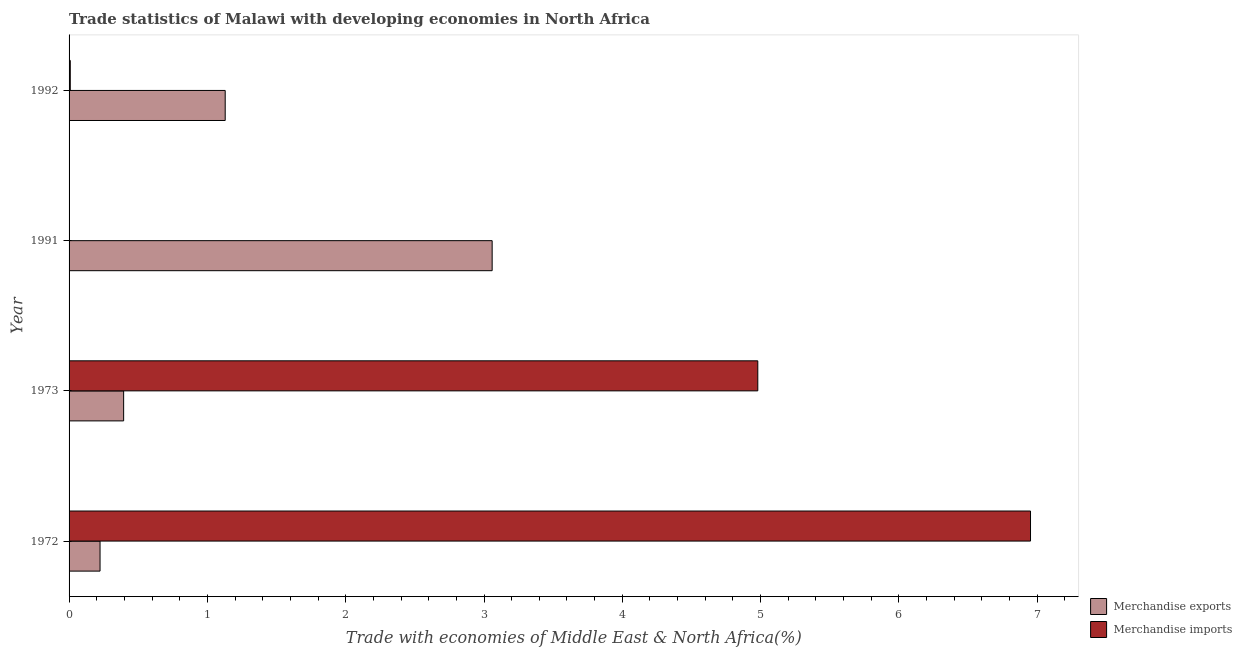Are the number of bars per tick equal to the number of legend labels?
Your response must be concise. Yes. Are the number of bars on each tick of the Y-axis equal?
Offer a very short reply. Yes. How many bars are there on the 2nd tick from the bottom?
Provide a succinct answer. 2. What is the label of the 3rd group of bars from the top?
Offer a terse response. 1973. In how many cases, is the number of bars for a given year not equal to the number of legend labels?
Provide a succinct answer. 0. What is the merchandise imports in 1972?
Keep it short and to the point. 6.95. Across all years, what is the maximum merchandise exports?
Offer a terse response. 3.06. Across all years, what is the minimum merchandise exports?
Your response must be concise. 0.22. What is the total merchandise imports in the graph?
Provide a succinct answer. 11.94. What is the difference between the merchandise exports in 1972 and that in 1991?
Provide a succinct answer. -2.83. What is the difference between the merchandise imports in 1972 and the merchandise exports in 1991?
Offer a terse response. 3.89. What is the average merchandise imports per year?
Ensure brevity in your answer.  2.98. In the year 1992, what is the difference between the merchandise imports and merchandise exports?
Ensure brevity in your answer.  -1.12. In how many years, is the merchandise exports greater than 3.8 %?
Offer a very short reply. 0. What is the ratio of the merchandise imports in 1972 to that in 1992?
Your answer should be very brief. 805.61. What is the difference between the highest and the second highest merchandise imports?
Provide a succinct answer. 1.97. What is the difference between the highest and the lowest merchandise exports?
Your response must be concise. 2.83. Is the sum of the merchandise imports in 1972 and 1992 greater than the maximum merchandise exports across all years?
Your response must be concise. Yes. How many bars are there?
Offer a very short reply. 8. Are all the bars in the graph horizontal?
Give a very brief answer. Yes. What is the difference between two consecutive major ticks on the X-axis?
Provide a succinct answer. 1. Are the values on the major ticks of X-axis written in scientific E-notation?
Ensure brevity in your answer.  No. Does the graph contain any zero values?
Provide a short and direct response. No. Does the graph contain grids?
Your answer should be very brief. No. Where does the legend appear in the graph?
Offer a terse response. Bottom right. What is the title of the graph?
Provide a succinct answer. Trade statistics of Malawi with developing economies in North Africa. What is the label or title of the X-axis?
Make the answer very short. Trade with economies of Middle East & North Africa(%). What is the label or title of the Y-axis?
Provide a succinct answer. Year. What is the Trade with economies of Middle East & North Africa(%) of Merchandise exports in 1972?
Ensure brevity in your answer.  0.22. What is the Trade with economies of Middle East & North Africa(%) of Merchandise imports in 1972?
Keep it short and to the point. 6.95. What is the Trade with economies of Middle East & North Africa(%) in Merchandise exports in 1973?
Offer a terse response. 0.39. What is the Trade with economies of Middle East & North Africa(%) in Merchandise imports in 1973?
Make the answer very short. 4.98. What is the Trade with economies of Middle East & North Africa(%) in Merchandise exports in 1991?
Keep it short and to the point. 3.06. What is the Trade with economies of Middle East & North Africa(%) in Merchandise imports in 1991?
Provide a short and direct response. 0. What is the Trade with economies of Middle East & North Africa(%) in Merchandise exports in 1992?
Ensure brevity in your answer.  1.13. What is the Trade with economies of Middle East & North Africa(%) in Merchandise imports in 1992?
Offer a terse response. 0.01. Across all years, what is the maximum Trade with economies of Middle East & North Africa(%) in Merchandise exports?
Make the answer very short. 3.06. Across all years, what is the maximum Trade with economies of Middle East & North Africa(%) of Merchandise imports?
Your response must be concise. 6.95. Across all years, what is the minimum Trade with economies of Middle East & North Africa(%) in Merchandise exports?
Offer a very short reply. 0.22. Across all years, what is the minimum Trade with economies of Middle East & North Africa(%) in Merchandise imports?
Offer a very short reply. 0. What is the total Trade with economies of Middle East & North Africa(%) in Merchandise exports in the graph?
Offer a very short reply. 4.81. What is the total Trade with economies of Middle East & North Africa(%) in Merchandise imports in the graph?
Your response must be concise. 11.94. What is the difference between the Trade with economies of Middle East & North Africa(%) of Merchandise exports in 1972 and that in 1973?
Offer a very short reply. -0.17. What is the difference between the Trade with economies of Middle East & North Africa(%) of Merchandise imports in 1972 and that in 1973?
Provide a short and direct response. 1.97. What is the difference between the Trade with economies of Middle East & North Africa(%) of Merchandise exports in 1972 and that in 1991?
Your response must be concise. -2.83. What is the difference between the Trade with economies of Middle East & North Africa(%) of Merchandise imports in 1972 and that in 1991?
Provide a short and direct response. 6.95. What is the difference between the Trade with economies of Middle East & North Africa(%) in Merchandise exports in 1972 and that in 1992?
Give a very brief answer. -0.9. What is the difference between the Trade with economies of Middle East & North Africa(%) in Merchandise imports in 1972 and that in 1992?
Keep it short and to the point. 6.94. What is the difference between the Trade with economies of Middle East & North Africa(%) in Merchandise exports in 1973 and that in 1991?
Provide a succinct answer. -2.66. What is the difference between the Trade with economies of Middle East & North Africa(%) of Merchandise imports in 1973 and that in 1991?
Provide a succinct answer. 4.98. What is the difference between the Trade with economies of Middle East & North Africa(%) in Merchandise exports in 1973 and that in 1992?
Your answer should be very brief. -0.73. What is the difference between the Trade with economies of Middle East & North Africa(%) of Merchandise imports in 1973 and that in 1992?
Your response must be concise. 4.97. What is the difference between the Trade with economies of Middle East & North Africa(%) in Merchandise exports in 1991 and that in 1992?
Make the answer very short. 1.93. What is the difference between the Trade with economies of Middle East & North Africa(%) of Merchandise imports in 1991 and that in 1992?
Your answer should be compact. -0.01. What is the difference between the Trade with economies of Middle East & North Africa(%) of Merchandise exports in 1972 and the Trade with economies of Middle East & North Africa(%) of Merchandise imports in 1973?
Make the answer very short. -4.76. What is the difference between the Trade with economies of Middle East & North Africa(%) of Merchandise exports in 1972 and the Trade with economies of Middle East & North Africa(%) of Merchandise imports in 1991?
Give a very brief answer. 0.22. What is the difference between the Trade with economies of Middle East & North Africa(%) in Merchandise exports in 1972 and the Trade with economies of Middle East & North Africa(%) in Merchandise imports in 1992?
Your answer should be compact. 0.22. What is the difference between the Trade with economies of Middle East & North Africa(%) in Merchandise exports in 1973 and the Trade with economies of Middle East & North Africa(%) in Merchandise imports in 1991?
Offer a very short reply. 0.39. What is the difference between the Trade with economies of Middle East & North Africa(%) of Merchandise exports in 1973 and the Trade with economies of Middle East & North Africa(%) of Merchandise imports in 1992?
Offer a terse response. 0.39. What is the difference between the Trade with economies of Middle East & North Africa(%) in Merchandise exports in 1991 and the Trade with economies of Middle East & North Africa(%) in Merchandise imports in 1992?
Make the answer very short. 3.05. What is the average Trade with economies of Middle East & North Africa(%) of Merchandise exports per year?
Provide a succinct answer. 1.2. What is the average Trade with economies of Middle East & North Africa(%) in Merchandise imports per year?
Your answer should be compact. 2.98. In the year 1972, what is the difference between the Trade with economies of Middle East & North Africa(%) in Merchandise exports and Trade with economies of Middle East & North Africa(%) in Merchandise imports?
Your answer should be compact. -6.73. In the year 1973, what is the difference between the Trade with economies of Middle East & North Africa(%) of Merchandise exports and Trade with economies of Middle East & North Africa(%) of Merchandise imports?
Keep it short and to the point. -4.59. In the year 1991, what is the difference between the Trade with economies of Middle East & North Africa(%) in Merchandise exports and Trade with economies of Middle East & North Africa(%) in Merchandise imports?
Keep it short and to the point. 3.06. In the year 1992, what is the difference between the Trade with economies of Middle East & North Africa(%) in Merchandise exports and Trade with economies of Middle East & North Africa(%) in Merchandise imports?
Keep it short and to the point. 1.12. What is the ratio of the Trade with economies of Middle East & North Africa(%) of Merchandise exports in 1972 to that in 1973?
Keep it short and to the point. 0.57. What is the ratio of the Trade with economies of Middle East & North Africa(%) of Merchandise imports in 1972 to that in 1973?
Provide a succinct answer. 1.4. What is the ratio of the Trade with economies of Middle East & North Africa(%) in Merchandise exports in 1972 to that in 1991?
Your response must be concise. 0.07. What is the ratio of the Trade with economies of Middle East & North Africa(%) in Merchandise imports in 1972 to that in 1991?
Your answer should be compact. 4.19e+04. What is the ratio of the Trade with economies of Middle East & North Africa(%) of Merchandise exports in 1972 to that in 1992?
Make the answer very short. 0.2. What is the ratio of the Trade with economies of Middle East & North Africa(%) in Merchandise imports in 1972 to that in 1992?
Your answer should be compact. 805.61. What is the ratio of the Trade with economies of Middle East & North Africa(%) in Merchandise exports in 1973 to that in 1991?
Your answer should be compact. 0.13. What is the ratio of the Trade with economies of Middle East & North Africa(%) of Merchandise imports in 1973 to that in 1991?
Provide a succinct answer. 3.00e+04. What is the ratio of the Trade with economies of Middle East & North Africa(%) of Merchandise exports in 1973 to that in 1992?
Ensure brevity in your answer.  0.35. What is the ratio of the Trade with economies of Middle East & North Africa(%) in Merchandise imports in 1973 to that in 1992?
Your answer should be very brief. 577.1. What is the ratio of the Trade with economies of Middle East & North Africa(%) of Merchandise exports in 1991 to that in 1992?
Your answer should be compact. 2.71. What is the ratio of the Trade with economies of Middle East & North Africa(%) in Merchandise imports in 1991 to that in 1992?
Give a very brief answer. 0.02. What is the difference between the highest and the second highest Trade with economies of Middle East & North Africa(%) in Merchandise exports?
Your answer should be compact. 1.93. What is the difference between the highest and the second highest Trade with economies of Middle East & North Africa(%) in Merchandise imports?
Offer a terse response. 1.97. What is the difference between the highest and the lowest Trade with economies of Middle East & North Africa(%) of Merchandise exports?
Provide a short and direct response. 2.83. What is the difference between the highest and the lowest Trade with economies of Middle East & North Africa(%) of Merchandise imports?
Offer a very short reply. 6.95. 